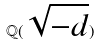<formula> <loc_0><loc_0><loc_500><loc_500>\mathbb { Q } ( \sqrt { - d } )</formula> 